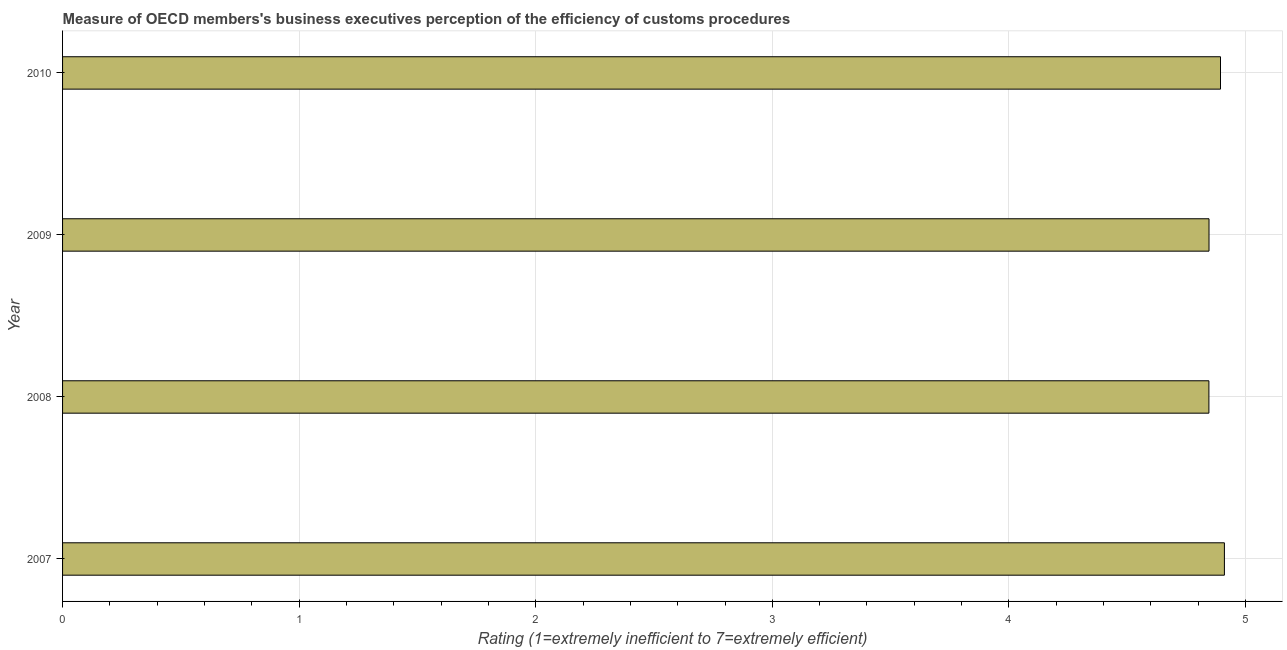Does the graph contain grids?
Your answer should be very brief. Yes. What is the title of the graph?
Provide a succinct answer. Measure of OECD members's business executives perception of the efficiency of customs procedures. What is the label or title of the X-axis?
Provide a short and direct response. Rating (1=extremely inefficient to 7=extremely efficient). What is the rating measuring burden of customs procedure in 2009?
Offer a terse response. 4.85. Across all years, what is the maximum rating measuring burden of customs procedure?
Your response must be concise. 4.91. Across all years, what is the minimum rating measuring burden of customs procedure?
Ensure brevity in your answer.  4.85. In which year was the rating measuring burden of customs procedure maximum?
Keep it short and to the point. 2007. In which year was the rating measuring burden of customs procedure minimum?
Keep it short and to the point. 2008. What is the sum of the rating measuring burden of customs procedure?
Keep it short and to the point. 19.5. What is the difference between the rating measuring burden of customs procedure in 2008 and 2009?
Ensure brevity in your answer.  -0. What is the average rating measuring burden of customs procedure per year?
Ensure brevity in your answer.  4.87. What is the median rating measuring burden of customs procedure?
Offer a very short reply. 4.87. In how many years, is the rating measuring burden of customs procedure greater than 1 ?
Ensure brevity in your answer.  4. Is the rating measuring burden of customs procedure in 2007 less than that in 2008?
Offer a very short reply. No. What is the difference between the highest and the second highest rating measuring burden of customs procedure?
Keep it short and to the point. 0.02. What is the difference between the highest and the lowest rating measuring burden of customs procedure?
Offer a very short reply. 0.07. In how many years, is the rating measuring burden of customs procedure greater than the average rating measuring burden of customs procedure taken over all years?
Make the answer very short. 2. How many bars are there?
Give a very brief answer. 4. Are the values on the major ticks of X-axis written in scientific E-notation?
Your answer should be compact. No. What is the Rating (1=extremely inefficient to 7=extremely efficient) of 2007?
Your answer should be very brief. 4.91. What is the Rating (1=extremely inefficient to 7=extremely efficient) of 2008?
Provide a short and direct response. 4.85. What is the Rating (1=extremely inefficient to 7=extremely efficient) of 2009?
Give a very brief answer. 4.85. What is the Rating (1=extremely inefficient to 7=extremely efficient) of 2010?
Your response must be concise. 4.89. What is the difference between the Rating (1=extremely inefficient to 7=extremely efficient) in 2007 and 2008?
Give a very brief answer. 0.07. What is the difference between the Rating (1=extremely inefficient to 7=extremely efficient) in 2007 and 2009?
Keep it short and to the point. 0.07. What is the difference between the Rating (1=extremely inefficient to 7=extremely efficient) in 2007 and 2010?
Your answer should be very brief. 0.02. What is the difference between the Rating (1=extremely inefficient to 7=extremely efficient) in 2008 and 2009?
Offer a very short reply. -0. What is the difference between the Rating (1=extremely inefficient to 7=extremely efficient) in 2008 and 2010?
Make the answer very short. -0.05. What is the difference between the Rating (1=extremely inefficient to 7=extremely efficient) in 2009 and 2010?
Keep it short and to the point. -0.05. What is the ratio of the Rating (1=extremely inefficient to 7=extremely efficient) in 2007 to that in 2008?
Your answer should be very brief. 1.01. What is the ratio of the Rating (1=extremely inefficient to 7=extremely efficient) in 2007 to that in 2009?
Provide a short and direct response. 1.01. 